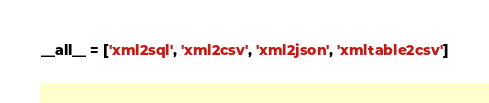Convert code to text. <code><loc_0><loc_0><loc_500><loc_500><_Python_>__all__ = ['xml2sql', 'xml2csv', 'xml2json', 'xmltable2csv']</code> 